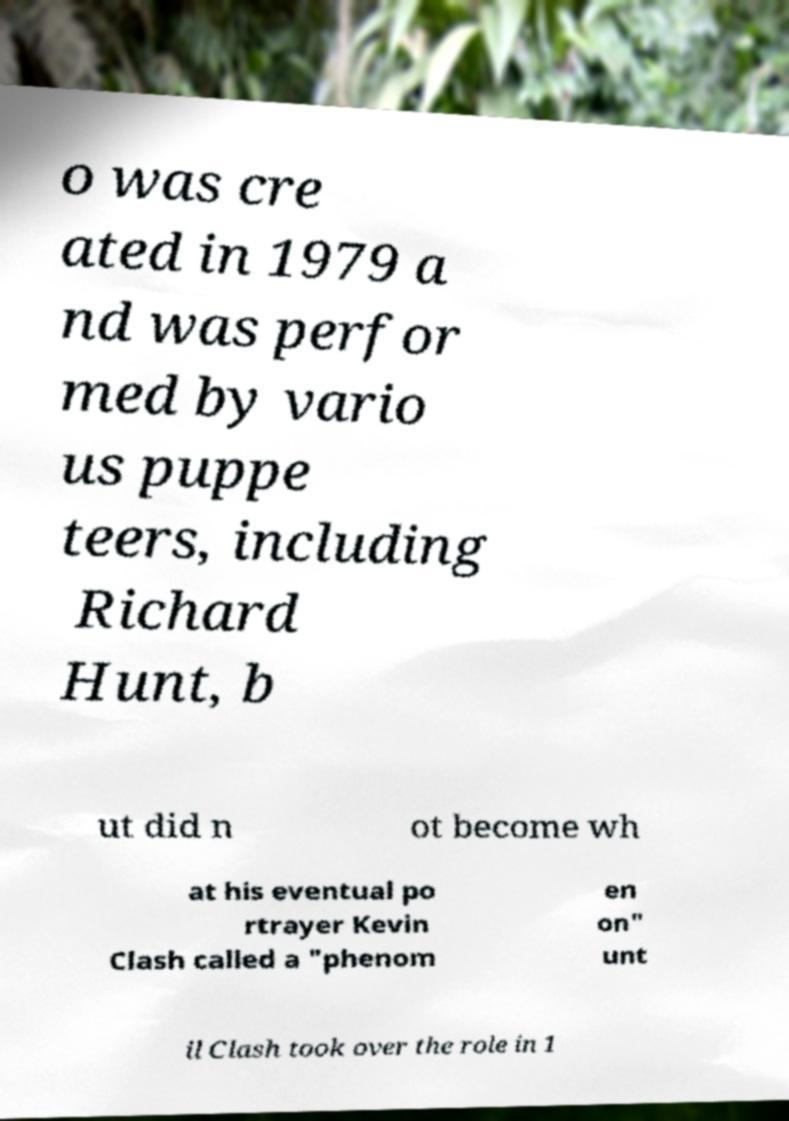Can you read and provide the text displayed in the image?This photo seems to have some interesting text. Can you extract and type it out for me? o was cre ated in 1979 a nd was perfor med by vario us puppe teers, including Richard Hunt, b ut did n ot become wh at his eventual po rtrayer Kevin Clash called a "phenom en on" unt il Clash took over the role in 1 